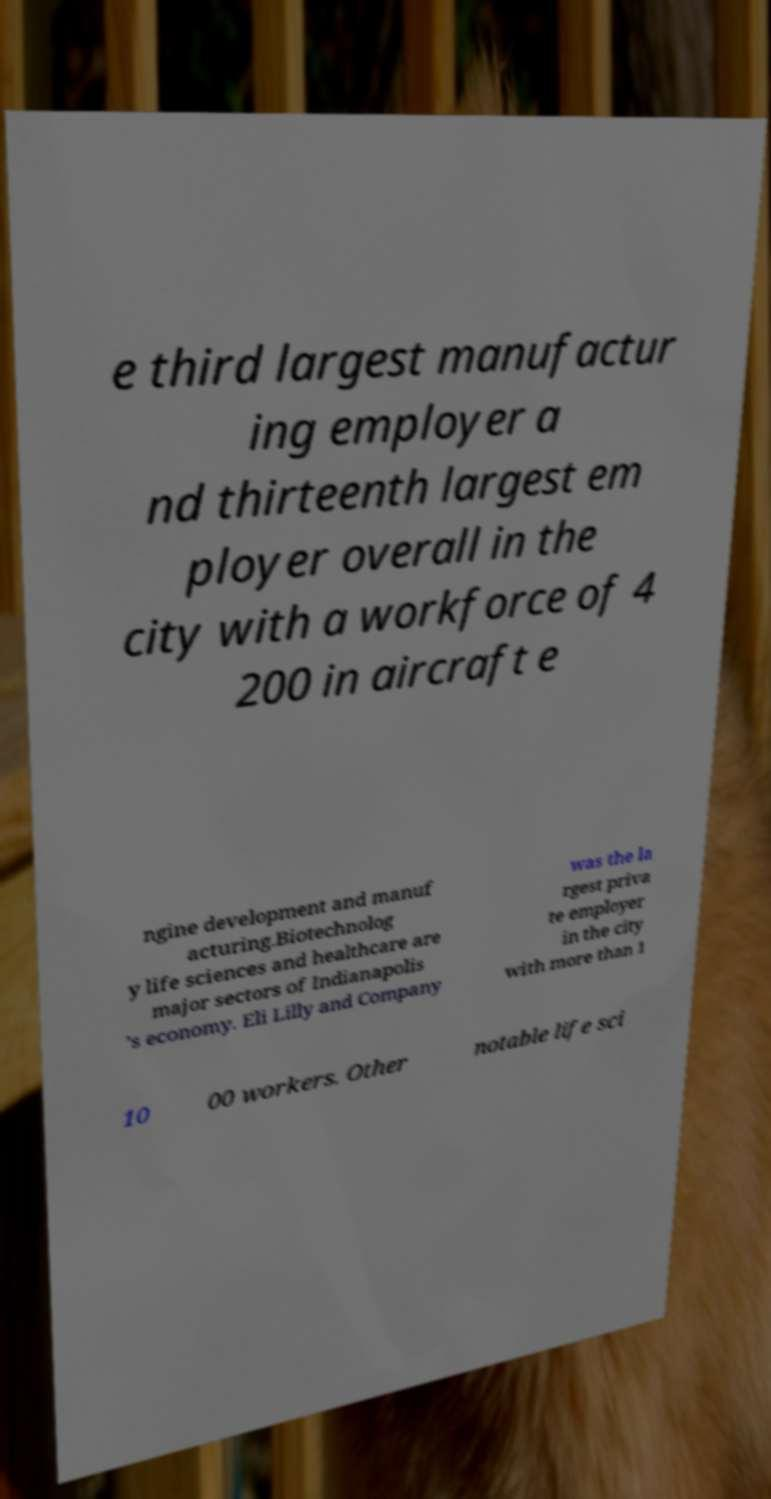Could you assist in decoding the text presented in this image and type it out clearly? e third largest manufactur ing employer a nd thirteenth largest em ployer overall in the city with a workforce of 4 200 in aircraft e ngine development and manuf acturing.Biotechnolog y life sciences and healthcare are major sectors of Indianapolis 's economy. Eli Lilly and Company was the la rgest priva te employer in the city with more than 1 10 00 workers. Other notable life sci 